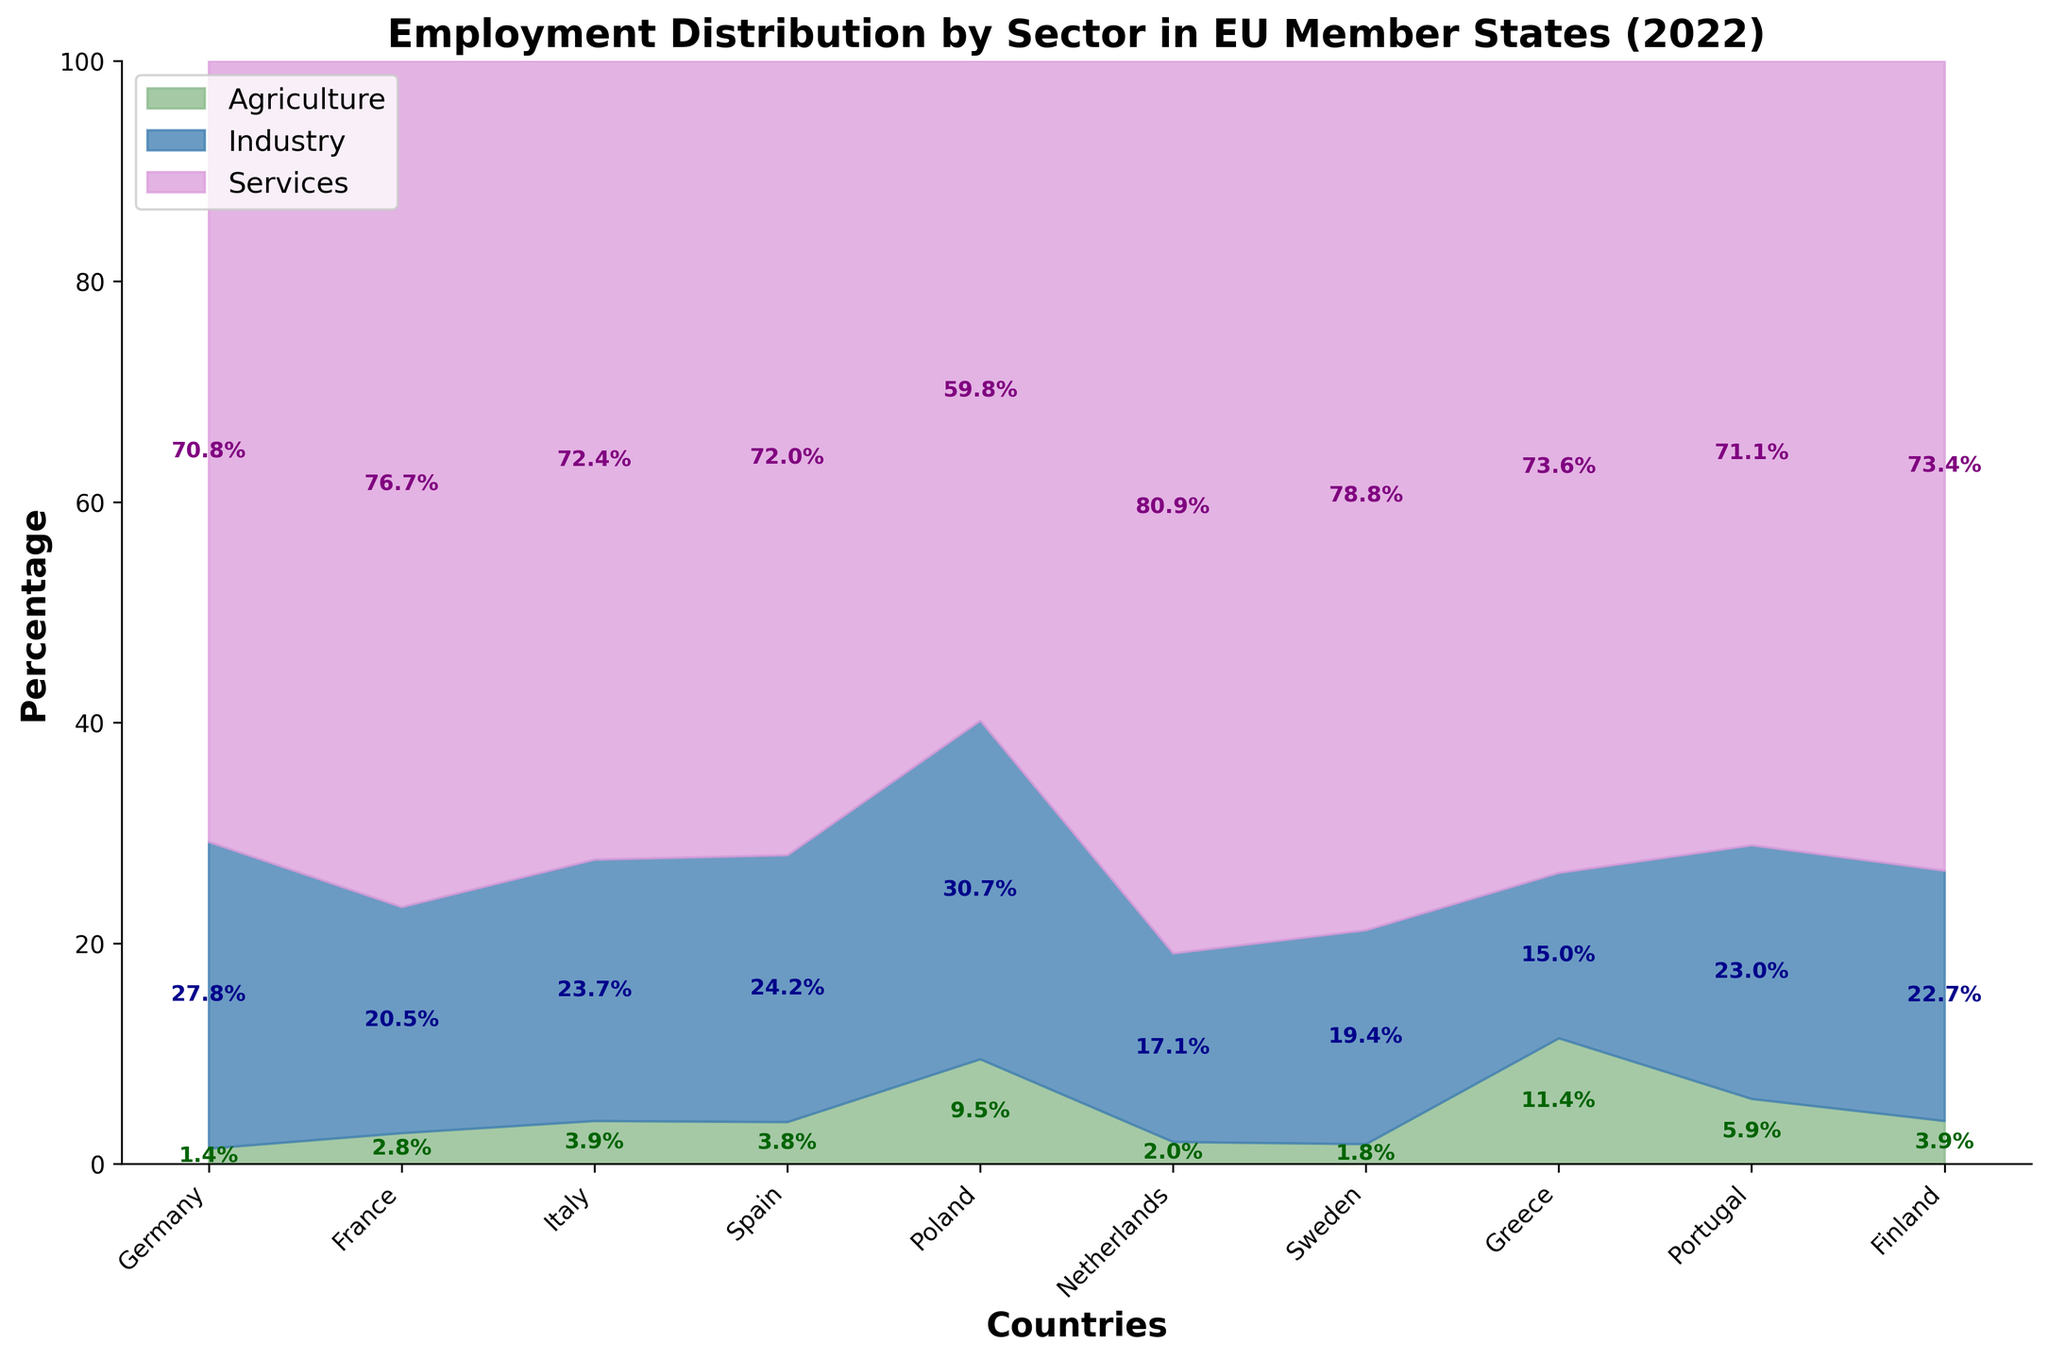What is the title of the figure? The title of the figure is located at the top and provides a summary of what the chart is about. Here, the title reads "Employment Distribution by Sector in EU Member States (2022)".
Answer: Employment Distribution by Sector in EU Member States (2022) Which country has the highest percentage of employment in agriculture? Look at the bottom part of the chart where the green area (representing agriculture) is the largest. According to the chart, Greece has the highest percentage of employment in agriculture at 11.4%.
Answer: Greece What is the approximate employment percentage in the services sector for Netherlands? Identify the purple area for Netherlands and read the text inside it. The chart shows that the percentage of employment in the services sector for Netherlands is 80.9%.
Answer: 80.9% Which country has the lowest employment percentage in the industry sector? Look at the blue area at the middle part of the chart for each country and find the smallest one. For Greece, the industry sector percentage is the smallest at 15.0%.
Answer: Greece What is the combined percentage of employment in agriculture and industry for Poland? First, identify the agriculture and industry percentages for Poland (9.5% and 30.7%, respectively). Add them together to get the result: 9.5 + 30.7 = 40.2%.
Answer: 40.2% Is the percentage of employment in services higher in Italy or Spain? Compare the purple areas for Italy and Spain. Italy has 72.4% and Spain has 72.0%. Italy's percentage in the services sector is higher.
Answer: Italy Which sector generally employs the most people across the EU countries shown? Look at the three stacked areas (green for agriculture, blue for industry, and purple for services) and see which one tends to dominate. The purple area is the largest across all countries, indicating that the services sector employs the most people.
Answer: Services How does the employment distribution in services differ between France and Germany? Compare the purple areas for services in France and Germany. France has 76.7% while Germany has 70.8%, showing France has a higher percentage of employment in services compared to Germany.
Answer: France has a higher percentage What is the average employment percentage in agriculture across all the countries? Add up all the agriculture percentages and divide by the number of countries: (1.4 + 2.8 + 3.9 + 3.8 + 9.5 + 2.0 + 1.8 + 11.4 + 5.9 + 3.9) / 10. The sum is 46.4, so the average is 46.4 / 10 = 4.64%.
Answer: 4.64% In which country is the employment distribution between industry and services the most balanced? Look for the country with the closest percentages between industry and services (the middle blue area and the top purple area being similar in size). Poland has 30.7% in industry and 59.8% in services, which is the closest ratio among all countries shown.
Answer: Poland 